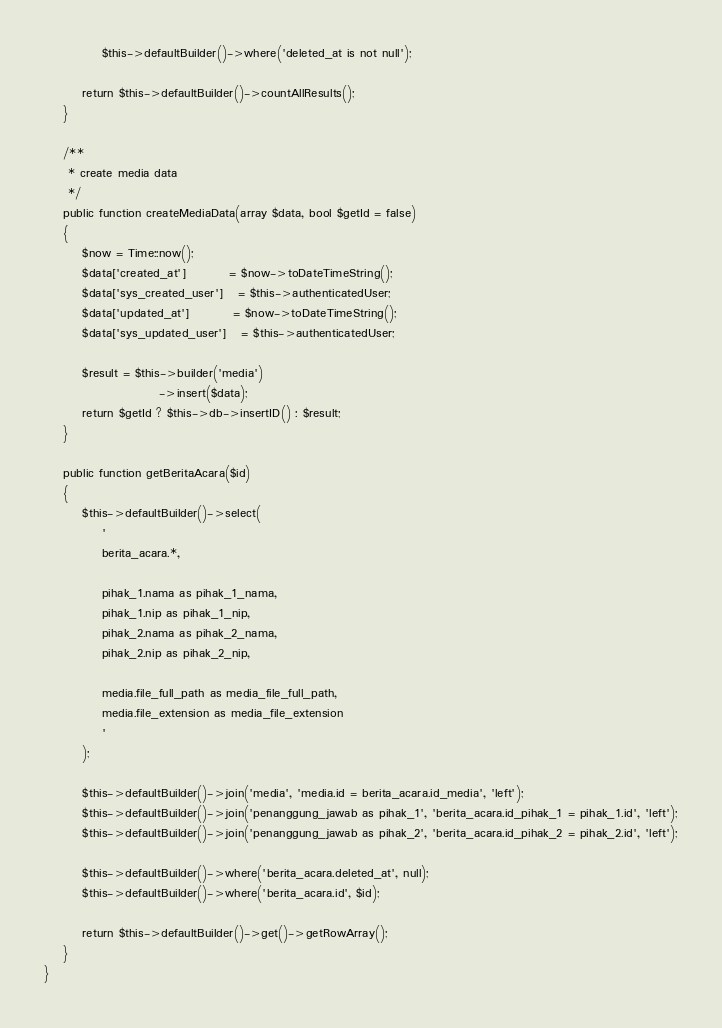<code> <loc_0><loc_0><loc_500><loc_500><_PHP_>            $this->defaultBuilder()->where('deleted_at is not null');
        
        return $this->defaultBuilder()->countAllResults();
    }

    /**
     * create media data
     */
    public function createMediaData(array $data, bool $getId = false)
    {
        $now = Time::now();
        $data['created_at']         = $now->toDateTimeString();
        $data['sys_created_user']   = $this->authenticatedUser;
        $data['updated_at']         = $now->toDateTimeString();
        $data['sys_updated_user']   = $this->authenticatedUser;
        
        $result = $this->builder('media')
                        ->insert($data);
        return $getId ? $this->db->insertID() : $result;
    }

    public function getBeritaAcara($id)
    {
        $this->defaultBuilder()->select(
            '
            berita_acara.*,

            pihak_1.nama as pihak_1_nama,
            pihak_1.nip as pihak_1_nip,
            pihak_2.nama as pihak_2_nama,
            pihak_2.nip as pihak_2_nip,

            media.file_full_path as media_file_full_path,
            media.file_extension as media_file_extension
            '
        );

        $this->defaultBuilder()->join('media', 'media.id = berita_acara.id_media', 'left');
        $this->defaultBuilder()->join('penanggung_jawab as pihak_1', 'berita_acara.id_pihak_1 = pihak_1.id', 'left');
        $this->defaultBuilder()->join('penanggung_jawab as pihak_2', 'berita_acara.id_pihak_2 = pihak_2.id', 'left');

        $this->defaultBuilder()->where('berita_acara.deleted_at', null);
        $this->defaultBuilder()->where('berita_acara.id', $id);

        return $this->defaultBuilder()->get()->getRowArray();
    }
}
</code> 